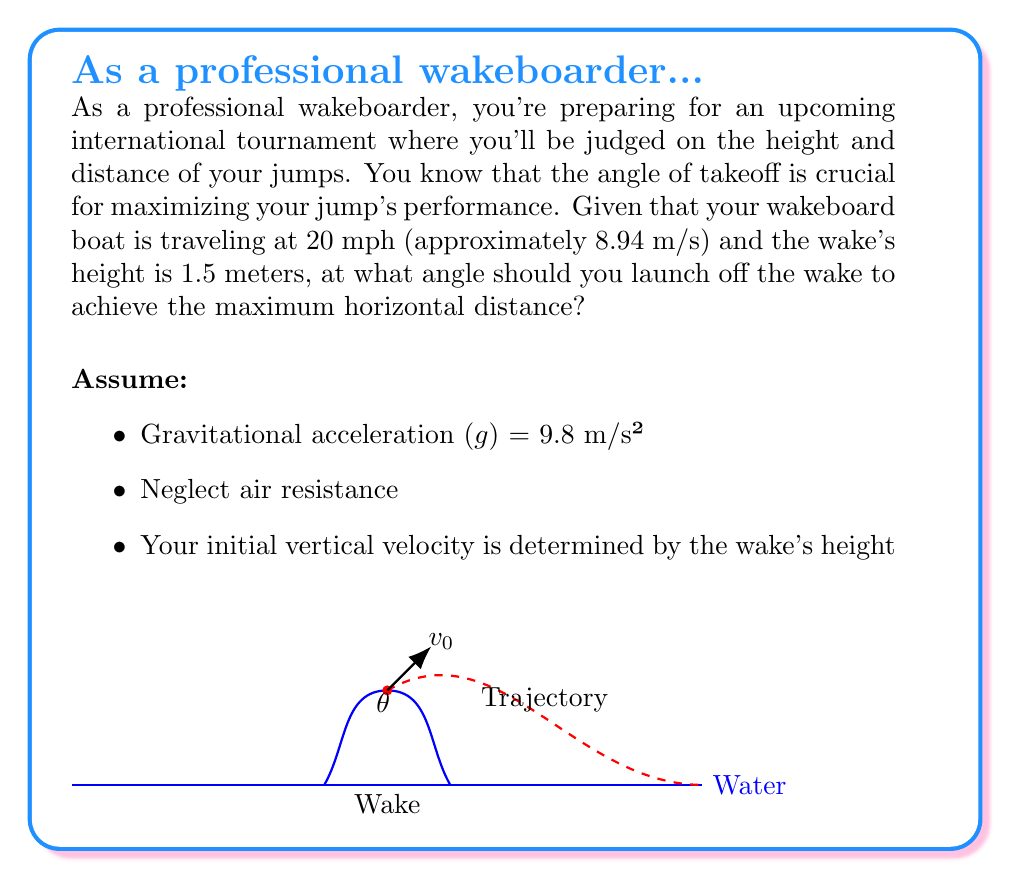Teach me how to tackle this problem. Let's approach this step-by-step:

1) First, we need to find the initial velocity (v₀) at the top of the wake. We can use the equation:

   $$v₀ = \sqrt{v_x^2 + v_y^2}$$

   Where $v_x$ is the horizontal velocity (boat speed) and $v_y$ is the vertical velocity at the top of the wake.

2) We know $v_x = 8.94$ m/s. To find $v_y$, we use the equation for velocity due to free fall:

   $$v_y = \sqrt{2gh}$$
   where $h$ is the height of the wake.

3) Plugging in the values:

   $$v_y = \sqrt{2 * 9.8 * 1.5} = 5.42$$ m/s

4) Now we can calculate $v₀$:

   $$v₀ = \sqrt{8.94^2 + 5.42^2} = 10.45$$ m/s

5) The range (R) of a projectile is given by the equation:

   $$R = \frac{v₀^2 \sin(2\theta)}{g}$$

   Where θ is the angle of launch.

6) To maximize R, we need to maximize $\sin(2\theta)$. This occurs when $2\theta = 90°$, or when $\theta = 45°$.

7) However, this is true only when the launch and landing are at the same height. In our case, we're launching from a height of 1.5m above the water.

8) For launches from an elevated position, the optimal angle is slightly less than 45°. The exact angle depends on the ratio of the launch height to the total range.

9) A good approximation for the optimal angle in this case is given by:

   $$\theta_{opt} \approx 45° - \frac{1}{2}\arctan(\frac{4h}{R})$$

   Where h is the launch height and R is the range at 45°.

10) We can calculate R at 45° using the equation from step 5:

    $$R = \frac{10.45^2 \sin(90°)}{9.8} = 11.14$$ m

11) Now we can solve for the optimal angle:

    $$\theta_{opt} \approx 45° - \frac{1}{2}\arctan(\frac{4*1.5}{11.14})$$
    $$\theta_{opt} \approx 45° - 3.8° = 41.2°$$

Therefore, the optimal angle for the wakeboard jump is approximately 41.2°.
Answer: 41.2° 